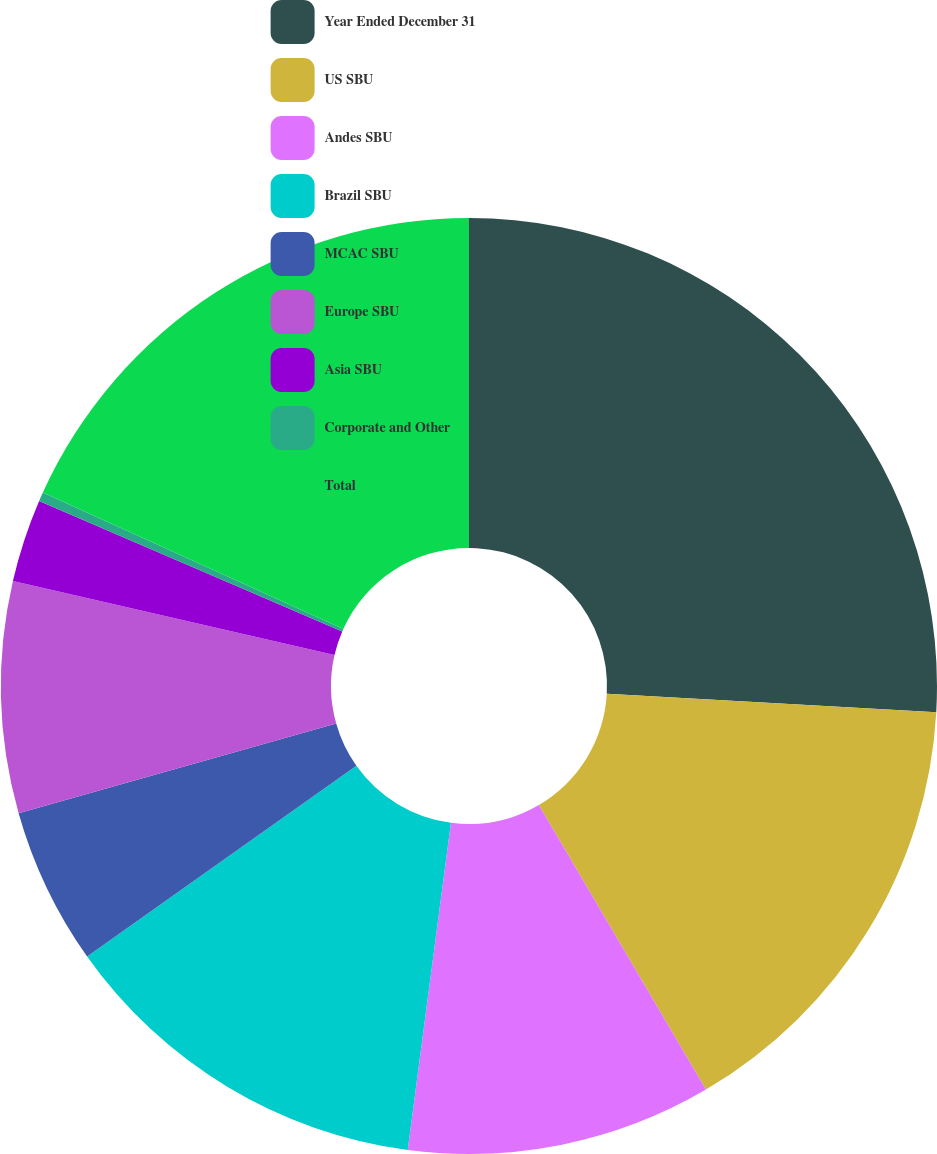Convert chart to OTSL. <chart><loc_0><loc_0><loc_500><loc_500><pie_chart><fcel>Year Ended December 31<fcel>US SBU<fcel>Andes SBU<fcel>Brazil SBU<fcel>MCAC SBU<fcel>Europe SBU<fcel>Asia SBU<fcel>Corporate and Other<fcel>Total<nl><fcel>25.89%<fcel>15.66%<fcel>10.54%<fcel>13.1%<fcel>5.43%<fcel>7.98%<fcel>2.87%<fcel>0.31%<fcel>18.22%<nl></chart> 